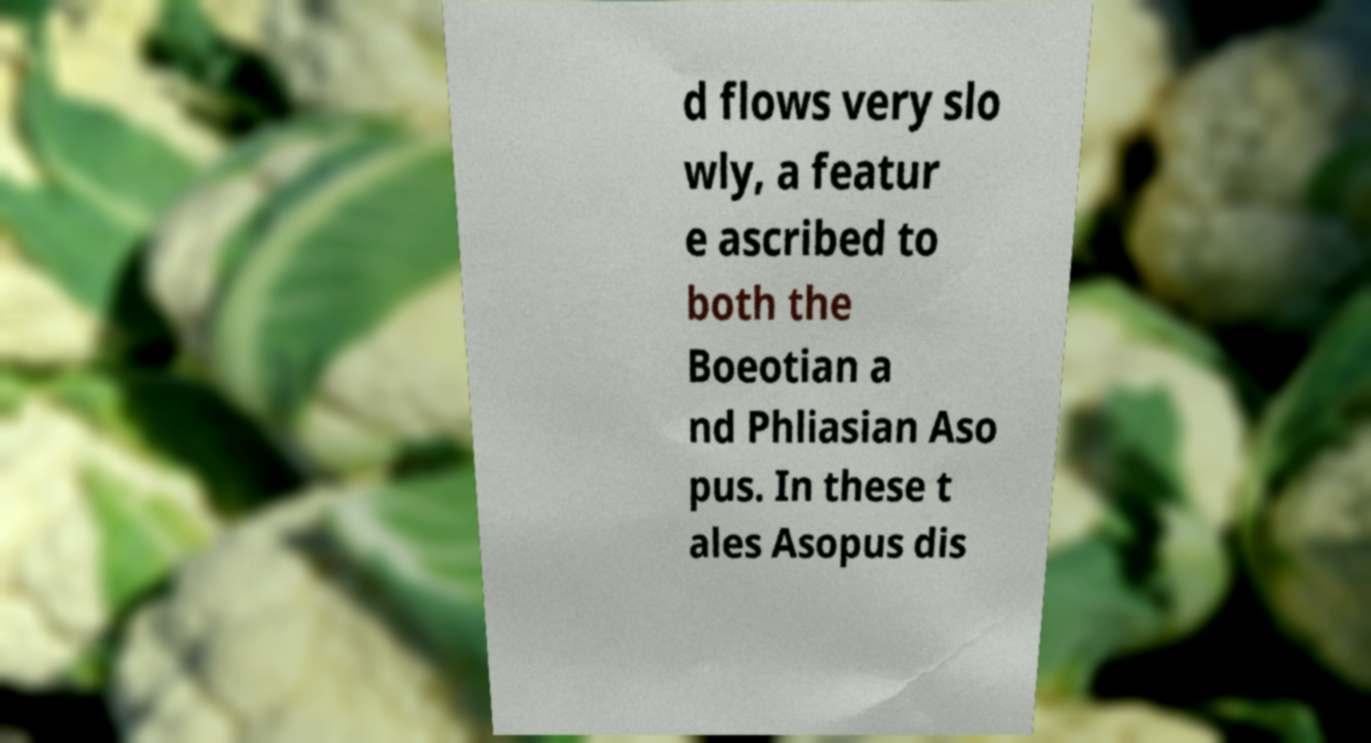Please identify and transcribe the text found in this image. d flows very slo wly, a featur e ascribed to both the Boeotian a nd Phliasian Aso pus. In these t ales Asopus dis 